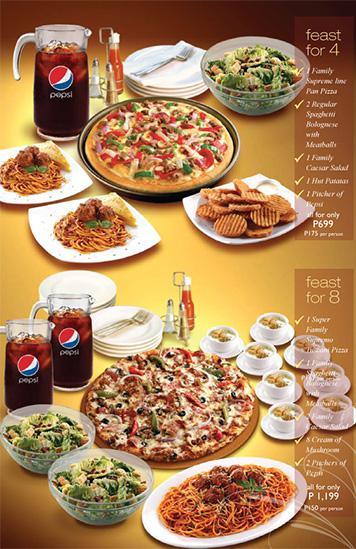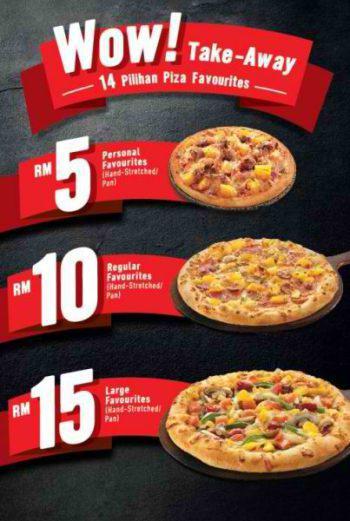The first image is the image on the left, the second image is the image on the right. Considering the images on both sides, is "The right image includes a cartoon clock and contains the same number of food items as the left image." valid? Answer yes or no. No. The first image is the image on the left, the second image is the image on the right. Given the left and right images, does the statement "In at least on image ad, there is both a pizza an at least three mozzarella sticks." hold true? Answer yes or no. No. 